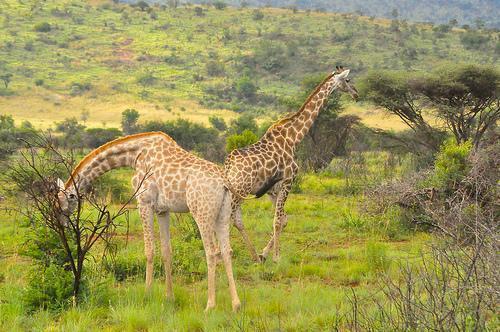How many giraffes are shown?
Give a very brief answer. 2. 